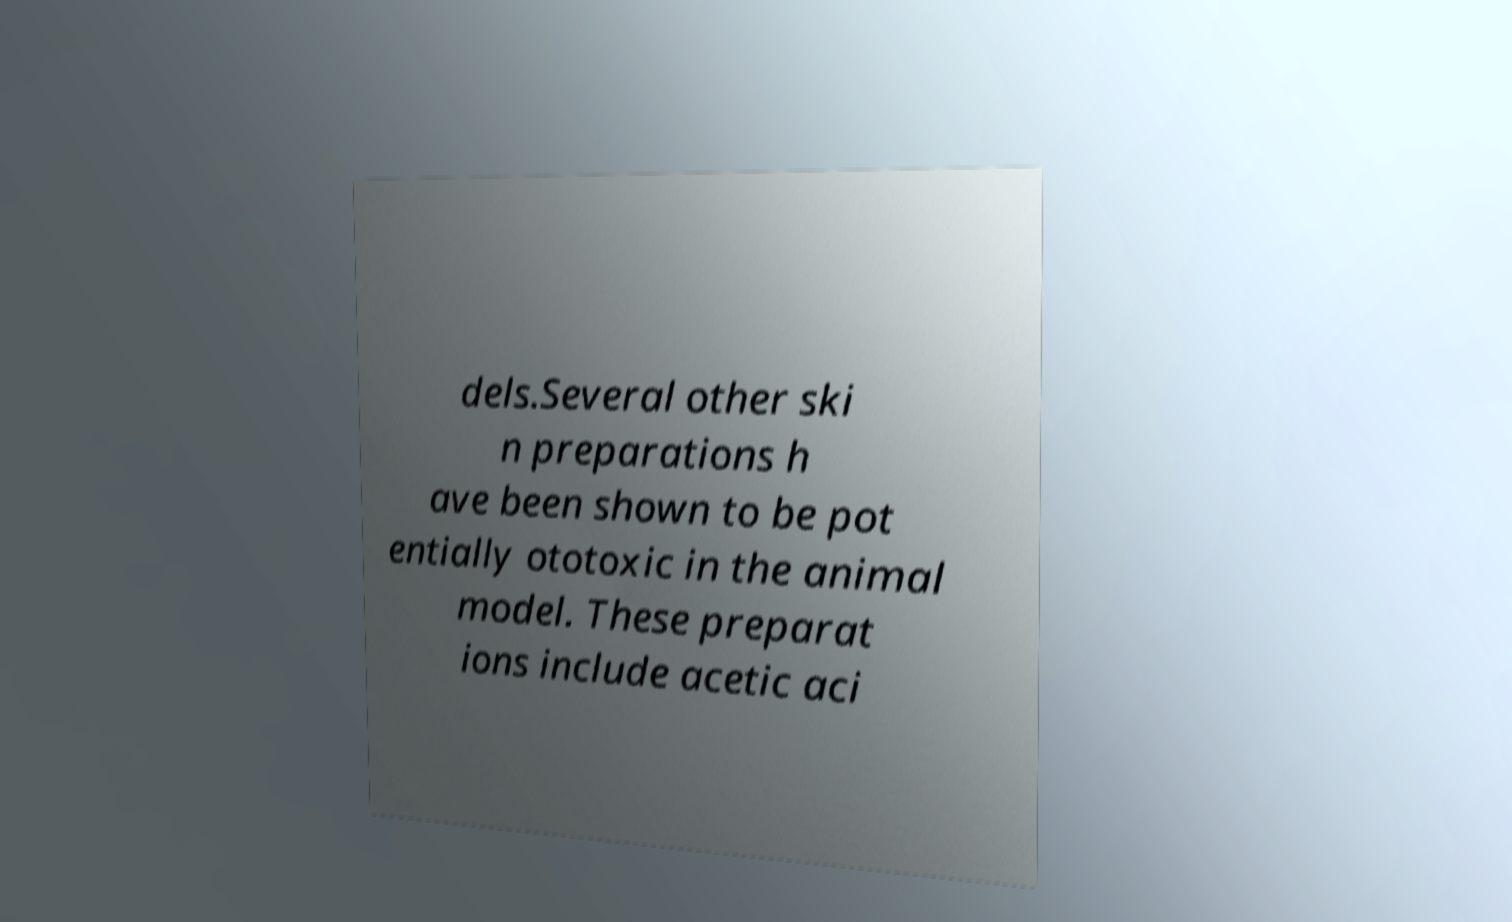For documentation purposes, I need the text within this image transcribed. Could you provide that? dels.Several other ski n preparations h ave been shown to be pot entially ototoxic in the animal model. These preparat ions include acetic aci 